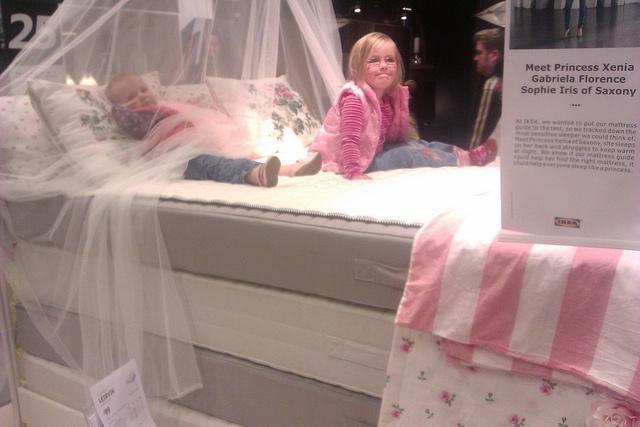Why is there a sign on the bed?
Select the accurate answer and provide justification: `Answer: choice
Rationale: srationale.`
Options: For fun, as joke, as decoration, to sell. Answer: to sell.
Rationale: There is a sign 9on the bed to sell it at ikea. 